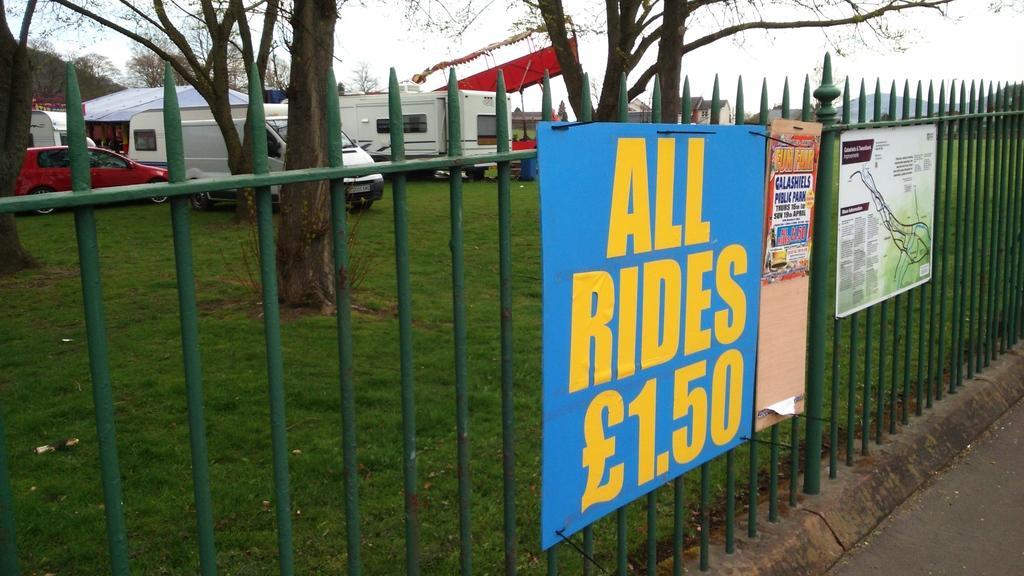Can you describe this image briefly? In this picture there is a boundary in the center of the image and there are posters on it and there are vehicles and trees in the background area of the image. 